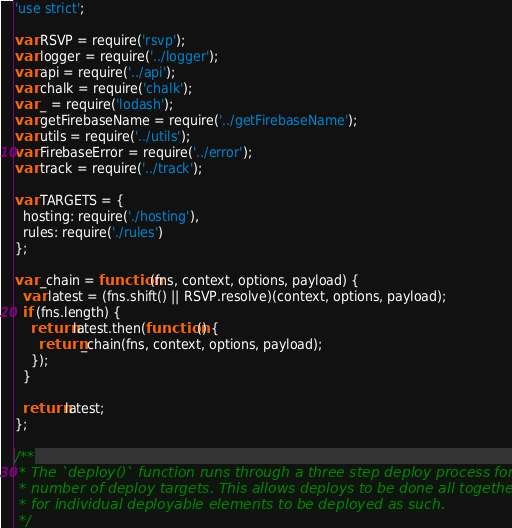<code> <loc_0><loc_0><loc_500><loc_500><_JavaScript_>'use strict';

var RSVP = require('rsvp');
var logger = require('../logger');
var api = require('../api');
var chalk = require('chalk');
var _ = require('lodash');
var getFirebaseName = require('../getFirebaseName');
var utils = require('../utils');
var FirebaseError = require('../error');
var track = require('../track');

var TARGETS = {
  hosting: require('./hosting'),
  rules: require('./rules')
};

var _chain = function(fns, context, options, payload) {
  var latest = (fns.shift() || RSVP.resolve)(context, options, payload);
  if (fns.length) {
    return latest.then(function() {
      return _chain(fns, context, options, payload);
    });
  }

  return latest;
};

/**
 * The `deploy()` function runs through a three step deploy process for a listed
 * number of deploy targets. This allows deploys to be done all together or
 * for individual deployable elements to be deployed as such.
 */</code> 